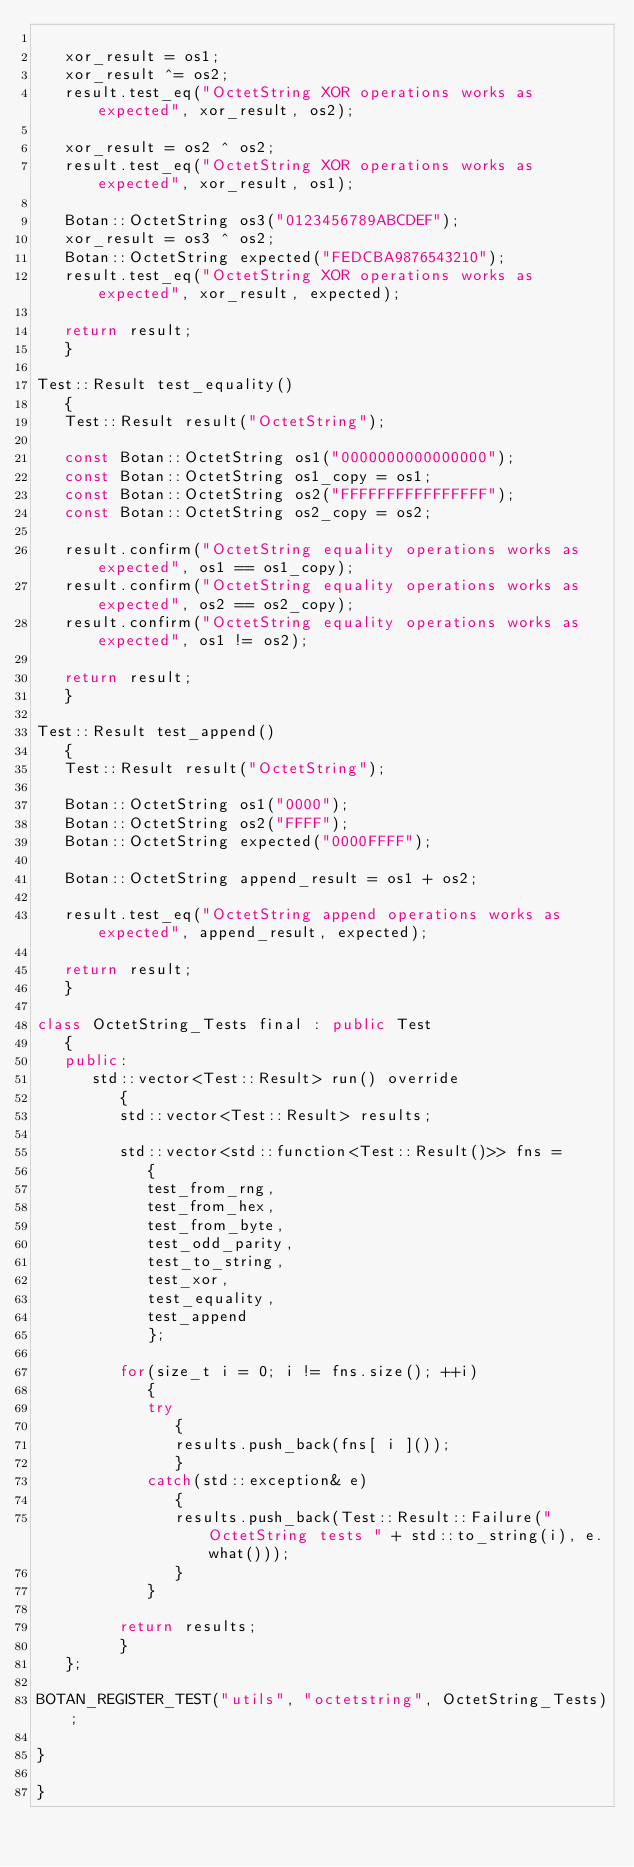Convert code to text. <code><loc_0><loc_0><loc_500><loc_500><_C++_>
   xor_result = os1;
   xor_result ^= os2;
   result.test_eq("OctetString XOR operations works as expected", xor_result, os2);

   xor_result = os2 ^ os2;
   result.test_eq("OctetString XOR operations works as expected", xor_result, os1);

   Botan::OctetString os3("0123456789ABCDEF");
   xor_result = os3 ^ os2;
   Botan::OctetString expected("FEDCBA9876543210");
   result.test_eq("OctetString XOR operations works as expected", xor_result, expected);

   return result;
   }

Test::Result test_equality()
   {
   Test::Result result("OctetString");

   const Botan::OctetString os1("0000000000000000");
   const Botan::OctetString os1_copy = os1;
   const Botan::OctetString os2("FFFFFFFFFFFFFFFF");
   const Botan::OctetString os2_copy = os2;

   result.confirm("OctetString equality operations works as expected", os1 == os1_copy);
   result.confirm("OctetString equality operations works as expected", os2 == os2_copy);
   result.confirm("OctetString equality operations works as expected", os1 != os2);

   return result;
   }

Test::Result test_append()
   {
   Test::Result result("OctetString");

   Botan::OctetString os1("0000");
   Botan::OctetString os2("FFFF");
   Botan::OctetString expected("0000FFFF");

   Botan::OctetString append_result = os1 + os2;

   result.test_eq("OctetString append operations works as expected", append_result, expected);

   return result;
   }

class OctetString_Tests final : public Test
   {
   public:
      std::vector<Test::Result> run() override
         {
         std::vector<Test::Result> results;

         std::vector<std::function<Test::Result()>> fns =
            {
            test_from_rng,
            test_from_hex,
            test_from_byte,
            test_odd_parity,
            test_to_string,
            test_xor,
            test_equality,
            test_append
            };

         for(size_t i = 0; i != fns.size(); ++i)
            {
            try
               {
               results.push_back(fns[ i ]());
               }
            catch(std::exception& e)
               {
               results.push_back(Test::Result::Failure("OctetString tests " + std::to_string(i), e.what()));
               }
            }

         return results;
         }
   };

BOTAN_REGISTER_TEST("utils", "octetstring", OctetString_Tests);

}

}
</code> 